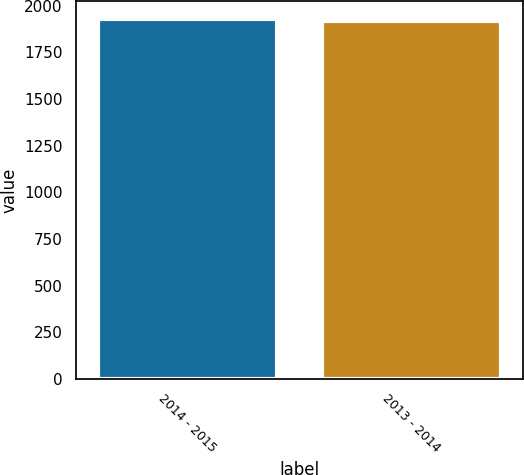Convert chart to OTSL. <chart><loc_0><loc_0><loc_500><loc_500><bar_chart><fcel>2014 - 2015<fcel>2013 - 2014<nl><fcel>1928.1<fcel>1917.9<nl></chart> 